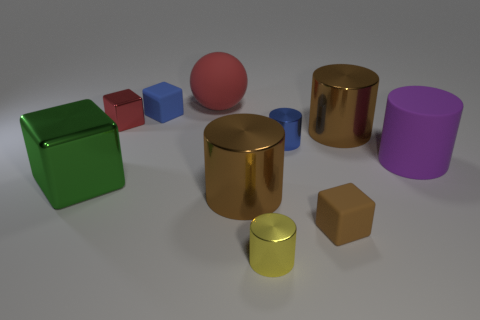There is a block that is the same color as the big sphere; what is its size?
Ensure brevity in your answer.  Small. There is a small brown object that is made of the same material as the small blue block; what shape is it?
Ensure brevity in your answer.  Cube. Is the size of the shiny object right of the brown rubber cube the same as the rubber thing in front of the big block?
Offer a very short reply. No. What color is the block on the right side of the small blue metal cylinder?
Your answer should be very brief. Brown. What is the material of the small blue thing on the left side of the big thing that is behind the small red object?
Offer a very short reply. Rubber. What shape is the blue shiny thing?
Provide a short and direct response. Cylinder. There is a tiny blue thing that is the same shape as the small red shiny thing; what is its material?
Offer a terse response. Rubber. How many spheres have the same size as the yellow shiny object?
Your response must be concise. 0. There is a matte thing that is in front of the green cube; are there any red rubber objects that are right of it?
Ensure brevity in your answer.  No. What number of brown things are either tiny shiny things or big matte things?
Offer a terse response. 0. 